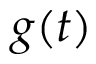<formula> <loc_0><loc_0><loc_500><loc_500>g ( t )</formula> 